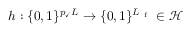<formula> <loc_0><loc_0><loc_500><loc_500>h \colon \{ 0 , 1 \} ^ { p _ { \check { m } a r k } L } \rightarrow \{ 0 , 1 \} ^ { L _ { f } } \in \mathcal { H }</formula> 